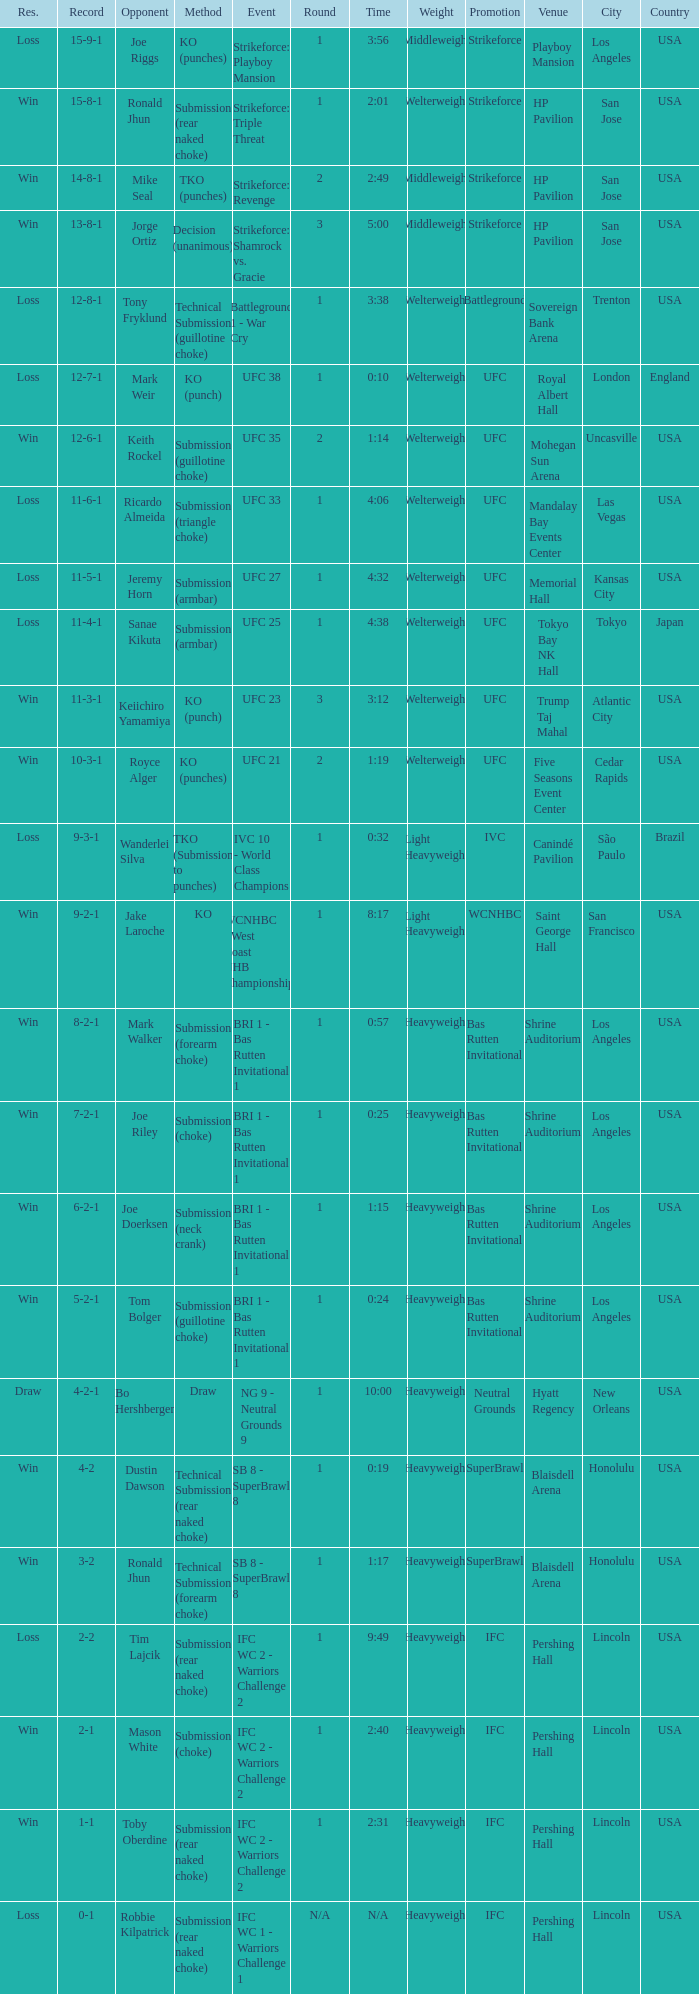Who was the opponent when the fight had a time of 2:01? Ronald Jhun. 